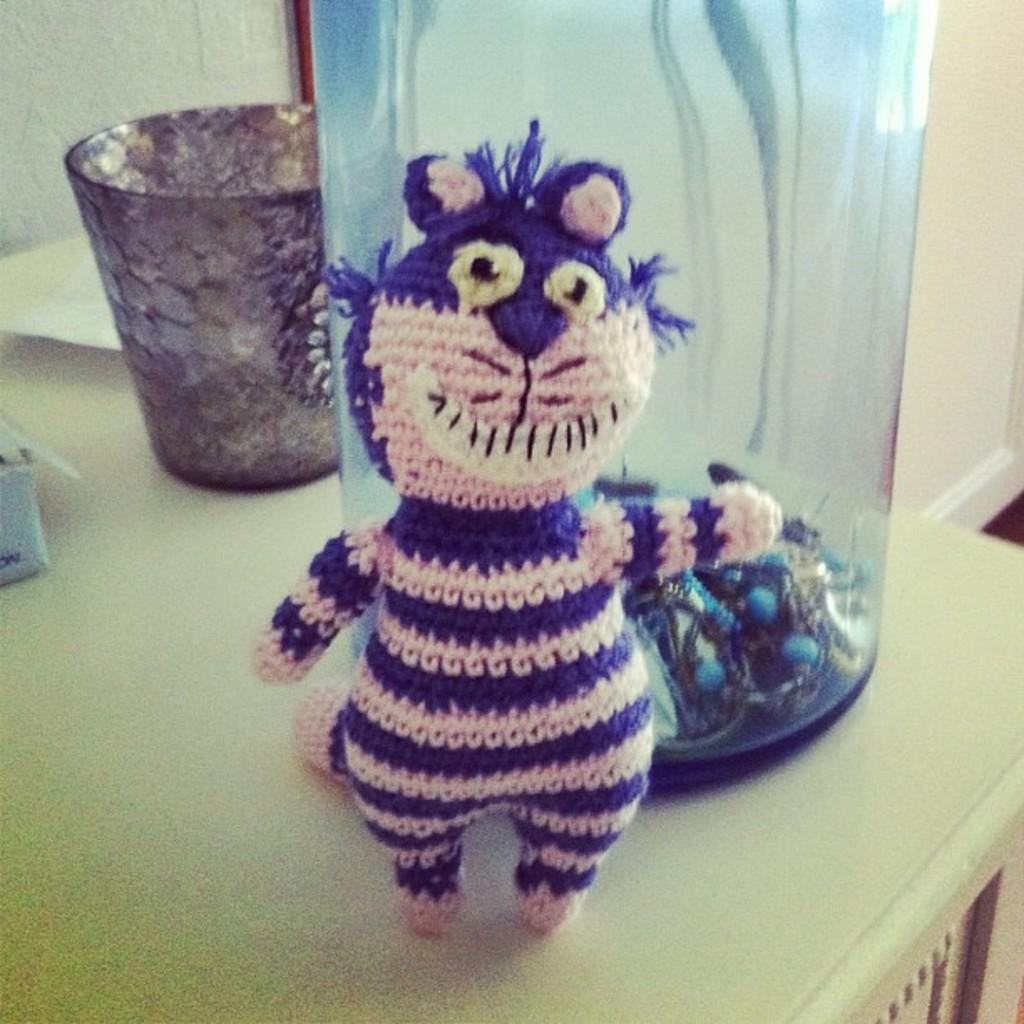What object is located at the front of the image? There is a toy in the front of the image. What can be seen in the middle of the image? There is a bottle in the middle of the image. Where is the glass positioned in the image? The glass is on the left side of the image. What is visible in the background of the image? There appears to be a wall in the background of the image. What type of pump is being used to inflate the toy in the image? There is no pump present in the image, and the toy does not appear to be inflatable. Can you describe the sponge that is being used to clean the glass in the image? There is no sponge visible in the image; only a glass is present. 